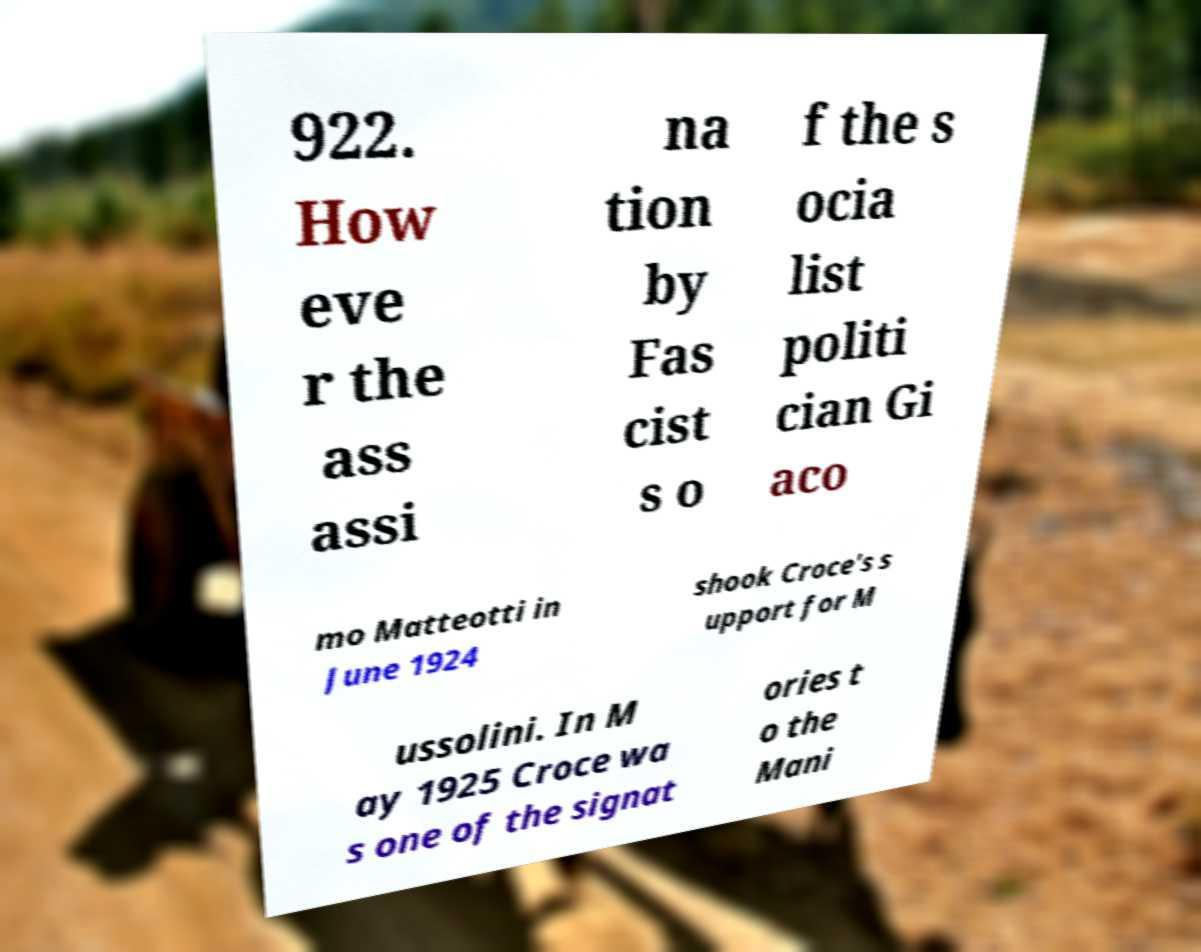Please identify and transcribe the text found in this image. 922. How eve r the ass assi na tion by Fas cist s o f the s ocia list politi cian Gi aco mo Matteotti in June 1924 shook Croce's s upport for M ussolini. In M ay 1925 Croce wa s one of the signat ories t o the Mani 